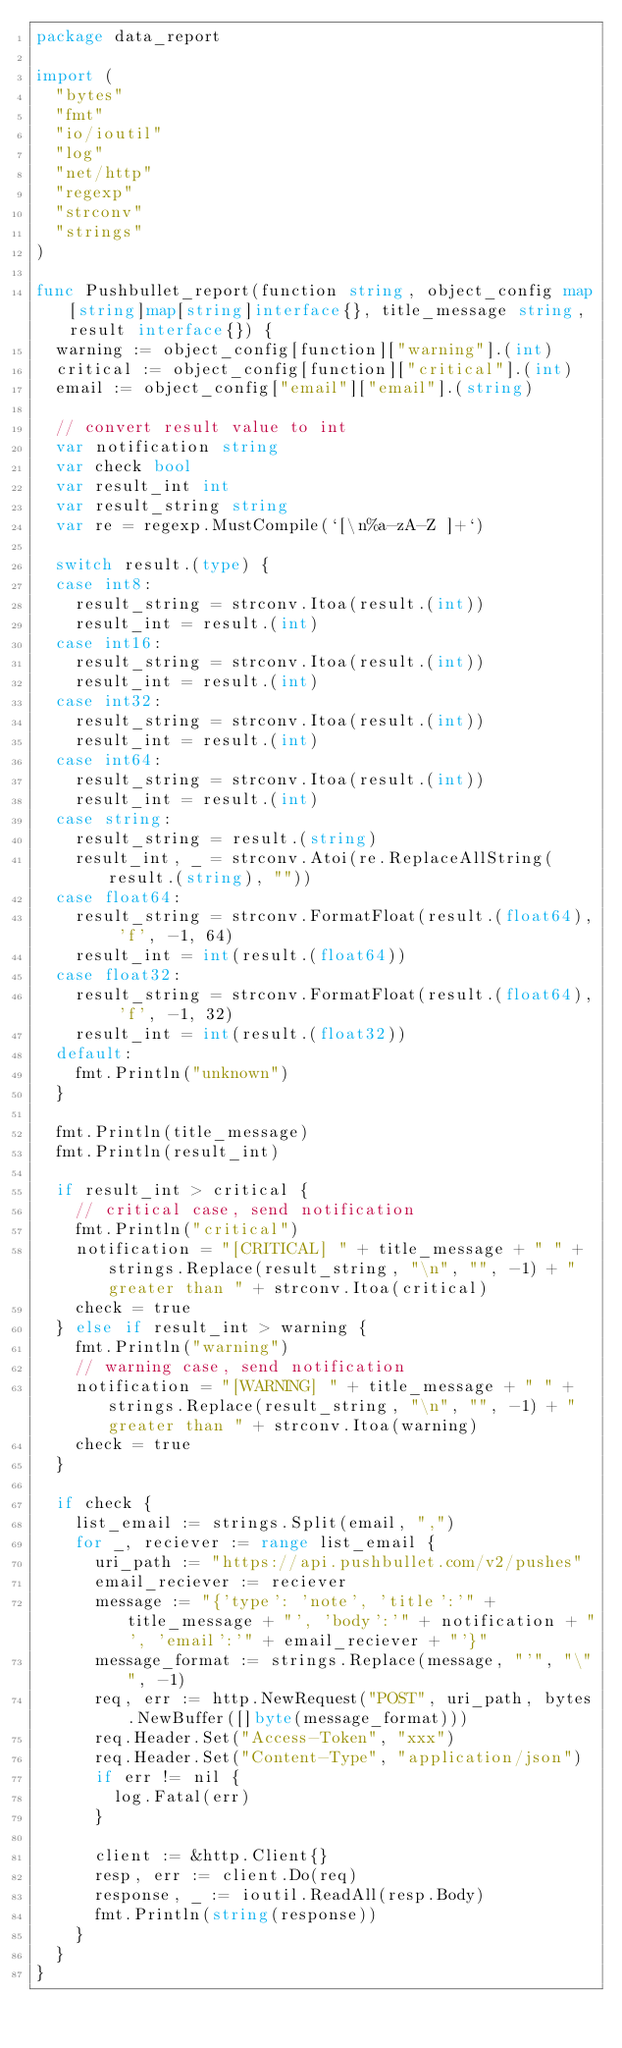<code> <loc_0><loc_0><loc_500><loc_500><_Go_>package data_report

import (
	"bytes"
	"fmt"
	"io/ioutil"
	"log"
	"net/http"
	"regexp"
	"strconv"
	"strings"
)

func Pushbullet_report(function string, object_config map[string]map[string]interface{}, title_message string, result interface{}) {
	warning := object_config[function]["warning"].(int)
	critical := object_config[function]["critical"].(int)
	email := object_config["email"]["email"].(string)

	// convert result value to int
	var notification string
	var check bool
	var result_int int
	var result_string string
	var re = regexp.MustCompile(`[\n%a-zA-Z ]+`)

	switch result.(type) {
	case int8:
		result_string = strconv.Itoa(result.(int))
		result_int = result.(int)
	case int16:
		result_string = strconv.Itoa(result.(int))
		result_int = result.(int)
	case int32:
		result_string = strconv.Itoa(result.(int))
		result_int = result.(int)
	case int64:
		result_string = strconv.Itoa(result.(int))
		result_int = result.(int)
	case string:
		result_string = result.(string)
		result_int, _ = strconv.Atoi(re.ReplaceAllString(result.(string), ""))
	case float64:
		result_string = strconv.FormatFloat(result.(float64), 'f', -1, 64)
		result_int = int(result.(float64))
	case float32:
		result_string = strconv.FormatFloat(result.(float64), 'f', -1, 32)
		result_int = int(result.(float32))
	default:
		fmt.Println("unknown")
	}

	fmt.Println(title_message)
	fmt.Println(result_int)

	if result_int > critical {
		// critical case, send notification
		fmt.Println("critical")
		notification = "[CRITICAL] " + title_message + " " + strings.Replace(result_string, "\n", "", -1) + " greater than " + strconv.Itoa(critical)
		check = true
	} else if result_int > warning {
		fmt.Println("warning")
		// warning case, send notification
		notification = "[WARNING] " + title_message + " " + strings.Replace(result_string, "\n", "", -1) + " greater than " + strconv.Itoa(warning)
		check = true
	}

	if check {
		list_email := strings.Split(email, ",")
		for _, reciever := range list_email {
			uri_path := "https://api.pushbullet.com/v2/pushes"
			email_reciever := reciever
			message := "{'type': 'note', 'title':'" + title_message + "', 'body':'" + notification + "', 'email':'" + email_reciever + "'}"
			message_format := strings.Replace(message, "'", "\"", -1)
			req, err := http.NewRequest("POST", uri_path, bytes.NewBuffer([]byte(message_format)))
			req.Header.Set("Access-Token", "xxx")
			req.Header.Set("Content-Type", "application/json")
			if err != nil {
				log.Fatal(err)
			}

			client := &http.Client{}
			resp, err := client.Do(req)
			response, _ := ioutil.ReadAll(resp.Body)
			fmt.Println(string(response))
		}
	}
}
</code> 